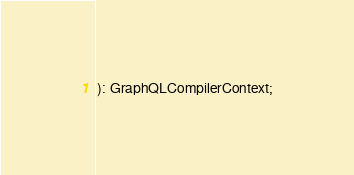Convert code to text. <code><loc_0><loc_0><loc_500><loc_500><_TypeScript_>): GraphQLCompilerContext;
</code> 